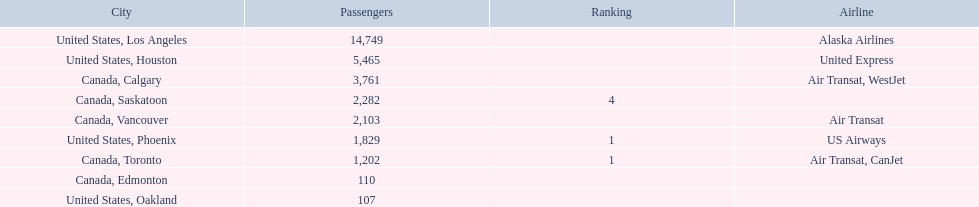What are the cities flown to? United States, Los Angeles, United States, Houston, Canada, Calgary, Canada, Saskatoon, Canada, Vancouver, United States, Phoenix, Canada, Toronto, Canada, Edmonton, United States, Oakland. What number of passengers did pheonix have? 1,829. 